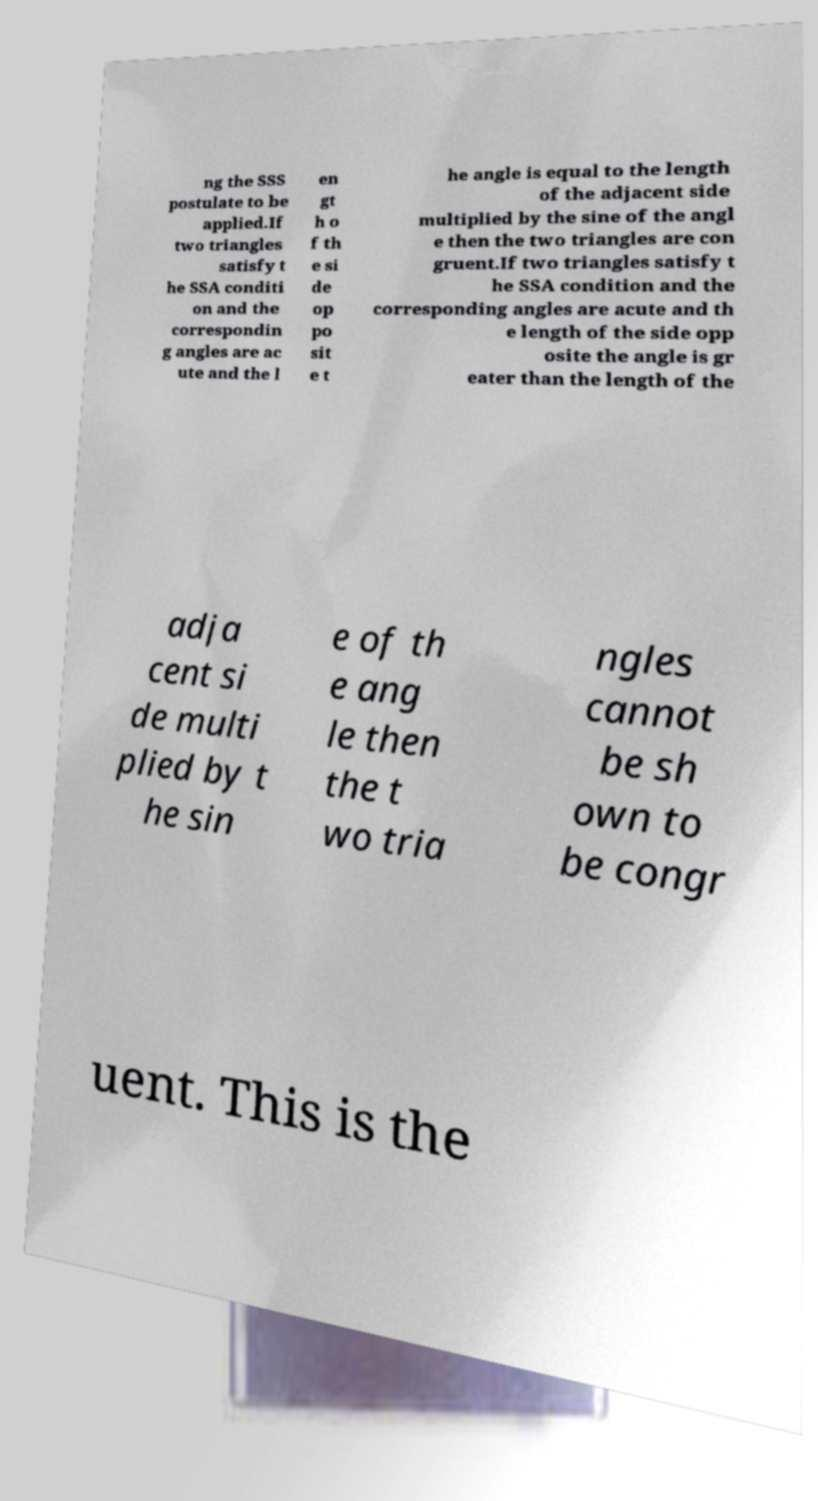Can you read and provide the text displayed in the image?This photo seems to have some interesting text. Can you extract and type it out for me? ng the SSS postulate to be applied.If two triangles satisfy t he SSA conditi on and the correspondin g angles are ac ute and the l en gt h o f th e si de op po sit e t he angle is equal to the length of the adjacent side multiplied by the sine of the angl e then the two triangles are con gruent.If two triangles satisfy t he SSA condition and the corresponding angles are acute and th e length of the side opp osite the angle is gr eater than the length of the adja cent si de multi plied by t he sin e of th e ang le then the t wo tria ngles cannot be sh own to be congr uent. This is the 